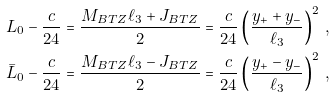<formula> <loc_0><loc_0><loc_500><loc_500>L _ { 0 } - \frac { c } { 2 4 } & = \frac { M _ { B T Z } \ell _ { 3 } + J _ { B T Z } } { 2 } = \frac { c } { 2 4 } \left ( \frac { y _ { + } + y _ { - } } { \ell _ { 3 } } \right ) ^ { 2 } \, , \\ \bar { L } _ { 0 } - \frac { c } { 2 4 } & = \frac { M _ { B T Z } \ell _ { 3 } - J _ { B T Z } } { 2 } = \frac { c } { 2 4 } \left ( \frac { y _ { + } - y _ { - } } { \ell _ { 3 } } \right ) ^ { 2 } \, ,</formula> 